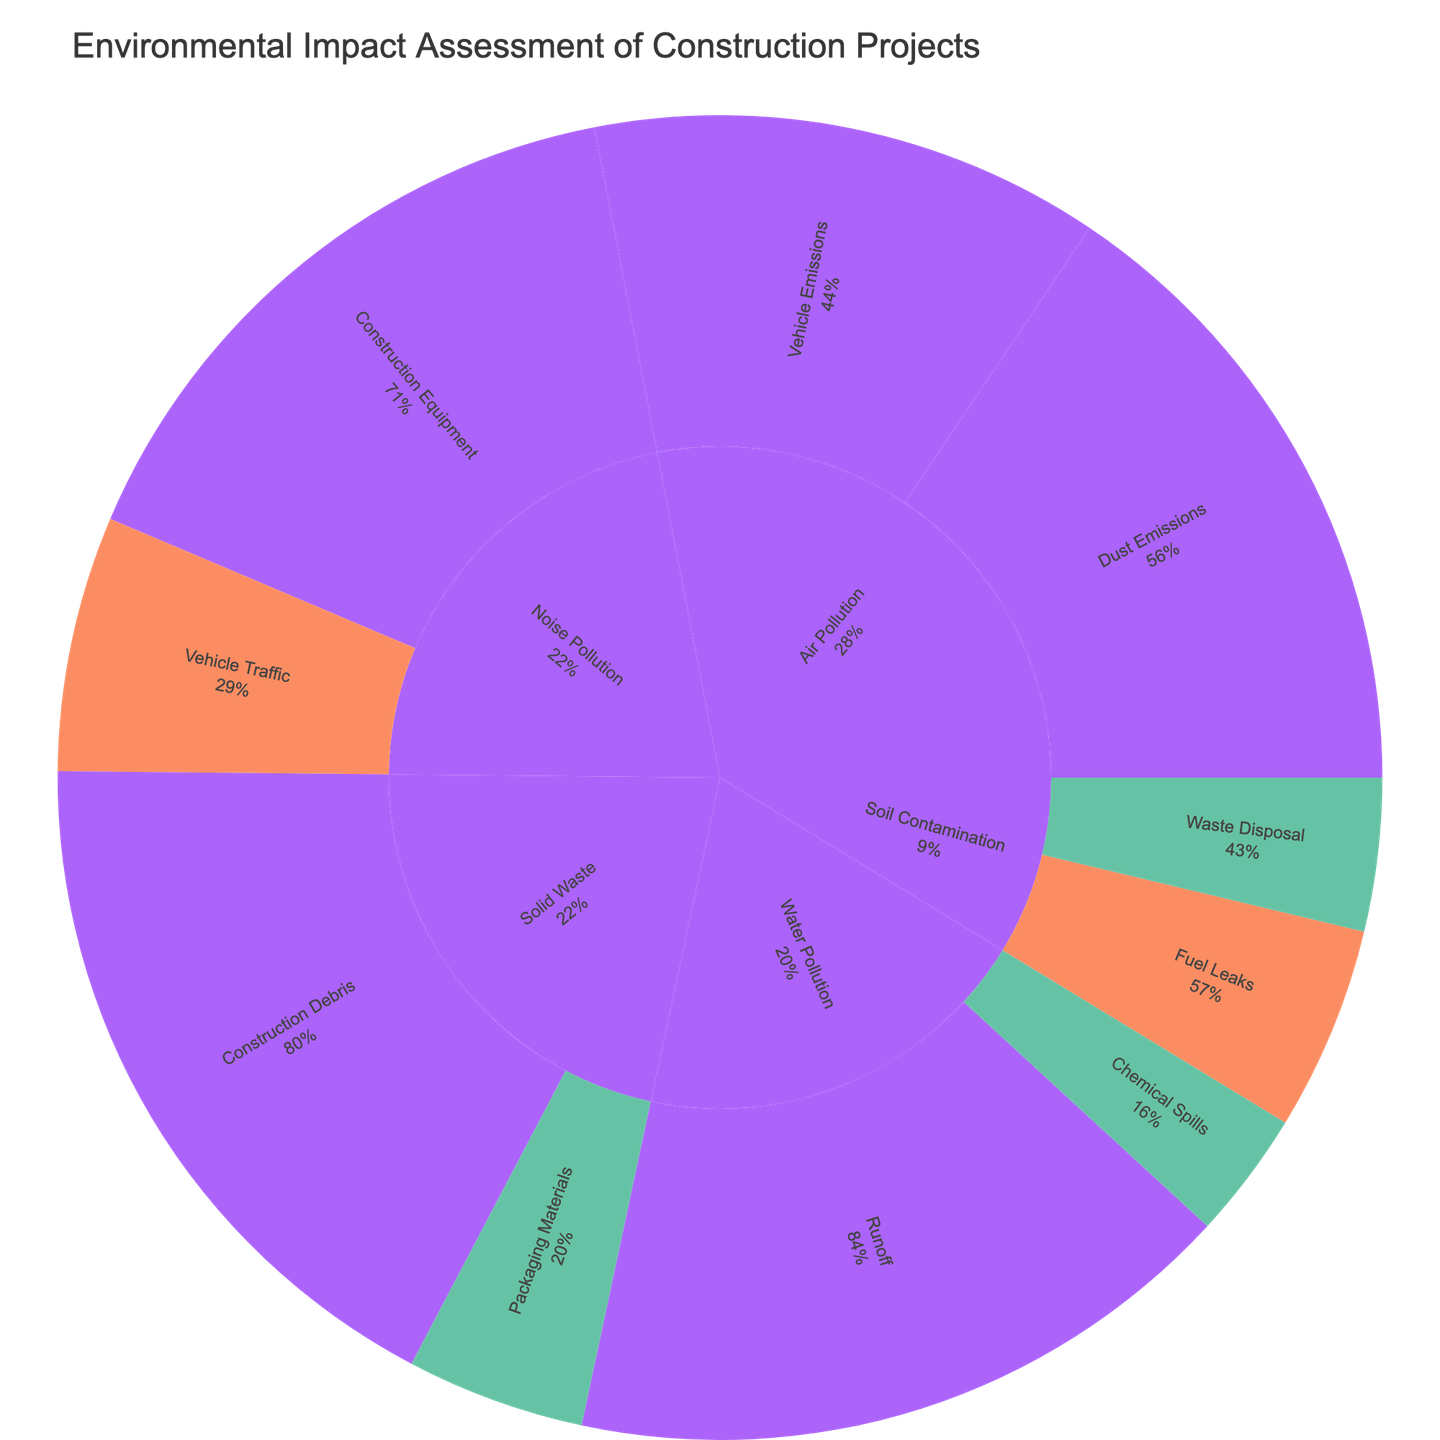What type of pollution has the highest severity for Water Pollution? The sunburst chart shows different categories of pollution types and their severities. For Water Pollution, the highest severity level displayed in the chart is 'High', which corresponds to Runoff with Sediment.
Answer: Runoff with Sediment What is the title of the figure? The title of the figure is typically displayed at the top of the chart. For this sunburst chart, it reads "Environmental Impact Assessment of Construction Projects".
Answer: Environmental Impact Assessment of Construction Projects Which has a greater impact in terms of value: Dust Emissions (PM10) or Construction Equipment (Excavators)? By comparing the values directly on the chart, Dust Emissions (PM10) has a value of 30, while Construction Equipment (Excavators) has a value of 28. Therefore, Dust Emissions (PM10) has a greater impact.
Answer: Dust Emissions (PM10) What is the combined value of all High severity impacts? To determine this, sum all the values with 'High' severity: Dust Emissions (PM10) 30, Vehicle Emissions (NOx) 25, Runoff (Sediment) 35, Construction Equipment (Excavators) 28, Construction Debris (Concrete) 32. The combined value is 30 + 25 + 35 + 28 + 32 = 150.
Answer: 150 Which subcategory within Solid Waste has the lowest value? Within the Solid Waste category, the subcategories are Construction Debris (Concrete: 32, Wood: 24) and Packaging Materials (Plastic: 14). Packaging Materials (Plastic) has the lowest value.
Answer: Packaging Materials (Plastic) How many categories have at least one subcategory with a High severity impact? From the sunburst plot, inspect each category for 'High' severity: Air Pollution (Dust Emissions: PM10), Water Pollution (Runoff: Sediment), Noise Pollution (Construction Equipment: Excavators), Solid Waste (Construction Debris: Concrete). Therefore, there are four categories.
Answer: 4 What percentage of parent is accounted by Medium severity Vehicle Traffic (Trucks) under Noise Pollution? Inspecting the chart, Vehicle Traffic (Trucks) has a 'value' and a percentage of parent. For this sunburst plot, Medium severity Vehicle Traffic (Trucks) accounts for a visible percentage based on its parent category, Noise Pollution. If the exact figure is given on the chart, use it directly (e.g., 20%).
Answer: 20% Which category has the highest total impact value? Sum up the values for each category: Air Pollution (30+20+25+15), Water Pollution (35+18+10), Noise Pollution (28+22+20), Soil Contamination (16+12), and Solid Waste (32+24+14). Calculate to find the highest total impact. Air Pollution: 30+20+25+15=90, Water Pollution: 35+18+10=63, Noise Pollution: 28+22+20=70, Soil Contamination: 16+12=28, Solid Waste: 32+24+14=70. So, Air Pollution has the highest total impact.
Answer: Air Pollution 